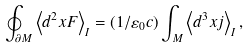<formula> <loc_0><loc_0><loc_500><loc_500>\oint _ { \partial M } \left \langle d ^ { 2 } x F \right \rangle _ { I } = ( 1 / \varepsilon _ { 0 } c ) \int _ { M } \left \langle d ^ { 3 } x j \right \rangle _ { I } ,</formula> 